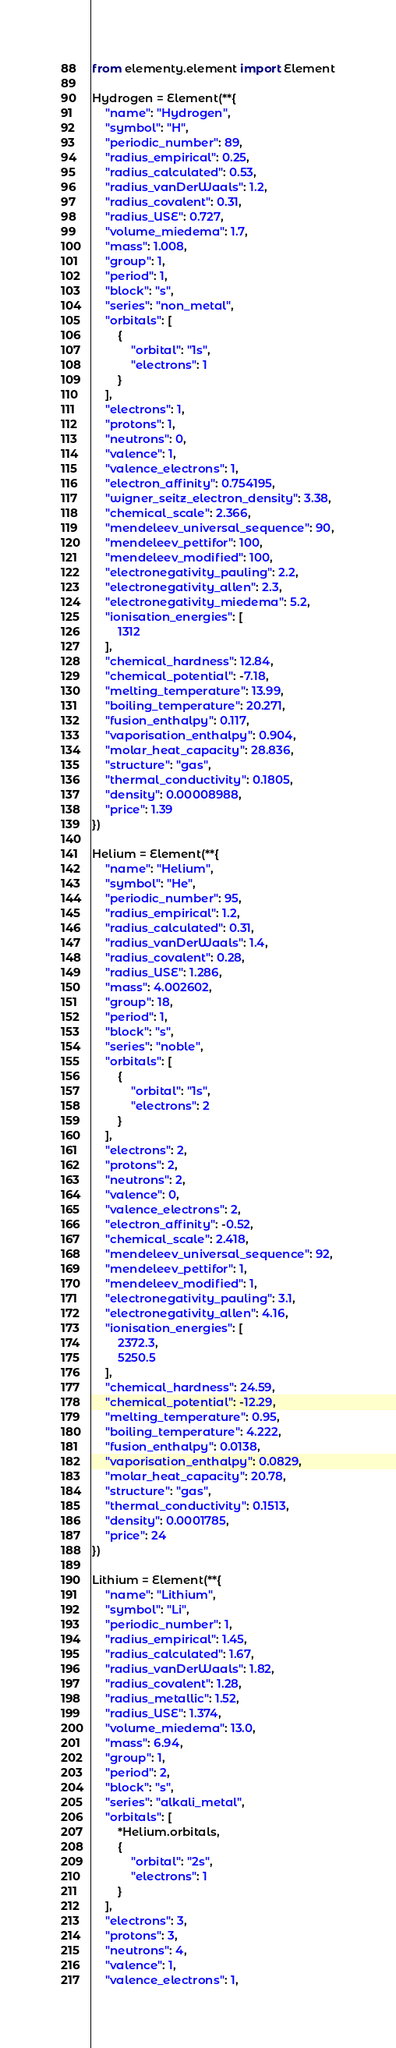<code> <loc_0><loc_0><loc_500><loc_500><_Python_>from elementy.element import Element

Hydrogen = Element(**{
    "name": "Hydrogen",
    "symbol": "H",
    "periodic_number": 89,
    "radius_empirical": 0.25,
    "radius_calculated": 0.53,
    "radius_vanDerWaals": 1.2,
    "radius_covalent": 0.31,
    "radius_USE": 0.727,
    "volume_miedema": 1.7,
    "mass": 1.008,
    "group": 1,
    "period": 1,
    "block": "s",
    "series": "non_metal",
    "orbitals": [
        {
            "orbital": "1s",
            "electrons": 1
        }
    ],
    "electrons": 1,
    "protons": 1,
    "neutrons": 0,
    "valence": 1,
    "valence_electrons": 1,
    "electron_affinity": 0.754195,
    "wigner_seitz_electron_density": 3.38,
    "chemical_scale": 2.366,
    "mendeleev_universal_sequence": 90,
    "mendeleev_pettifor": 100,
    "mendeleev_modified": 100,
    "electronegativity_pauling": 2.2,
    "electronegativity_allen": 2.3,
    "electronegativity_miedema": 5.2,
    "ionisation_energies": [
        1312
    ],
    "chemical_hardness": 12.84,
    "chemical_potential": -7.18,
    "melting_temperature": 13.99,
    "boiling_temperature": 20.271,
    "fusion_enthalpy": 0.117,
    "vaporisation_enthalpy": 0.904,
    "molar_heat_capacity": 28.836,
    "structure": "gas",
    "thermal_conductivity": 0.1805,
    "density": 0.00008988,
    "price": 1.39
})

Helium = Element(**{
    "name": "Helium",
    "symbol": "He",
    "periodic_number": 95,
    "radius_empirical": 1.2,
    "radius_calculated": 0.31,
    "radius_vanDerWaals": 1.4,
    "radius_covalent": 0.28,
    "radius_USE": 1.286,
    "mass": 4.002602,
    "group": 18,
    "period": 1,
    "block": "s",
    "series": "noble",
    "orbitals": [
        {
            "orbital": "1s",
            "electrons": 2
        }
    ],
    "electrons": 2,
    "protons": 2,
    "neutrons": 2,
    "valence": 0,
    "valence_electrons": 2,
    "electron_affinity": -0.52,
    "chemical_scale": 2.418,
    "mendeleev_universal_sequence": 92,
    "mendeleev_pettifor": 1,
    "mendeleev_modified": 1,
    "electronegativity_pauling": 3.1,
    "electronegativity_allen": 4.16,
    "ionisation_energies": [
        2372.3,
        5250.5
    ],
    "chemical_hardness": 24.59,
    "chemical_potential": -12.29,
    "melting_temperature": 0.95,
    "boiling_temperature": 4.222,
    "fusion_enthalpy": 0.0138,
    "vaporisation_enthalpy": 0.0829,
    "molar_heat_capacity": 20.78,
    "structure": "gas",
    "thermal_conductivity": 0.1513,
    "density": 0.0001785,
    "price": 24
})

Lithium = Element(**{
    "name": "Lithium",
    "symbol": "Li",
    "periodic_number": 1,
    "radius_empirical": 1.45,
    "radius_calculated": 1.67,
    "radius_vanDerWaals": 1.82,
    "radius_covalent": 1.28,
    "radius_metallic": 1.52,
    "radius_USE": 1.374,
    "volume_miedema": 13.0,
    "mass": 6.94,
    "group": 1,
    "period": 2,
    "block": "s",
    "series": "alkali_metal",
    "orbitals": [
        *Helium.orbitals,
        {
            "orbital": "2s",
            "electrons": 1
        }
    ],
    "electrons": 3,
    "protons": 3,
    "neutrons": 4,
    "valence": 1,
    "valence_electrons": 1,</code> 